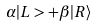<formula> <loc_0><loc_0><loc_500><loc_500>\alpha | L > + \beta | R \rangle</formula> 